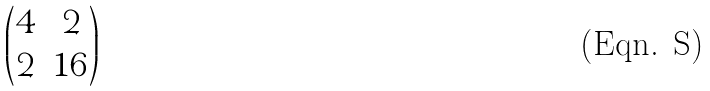<formula> <loc_0><loc_0><loc_500><loc_500>\begin{pmatrix} 4 & 2 \\ 2 & 1 6 \end{pmatrix}</formula> 